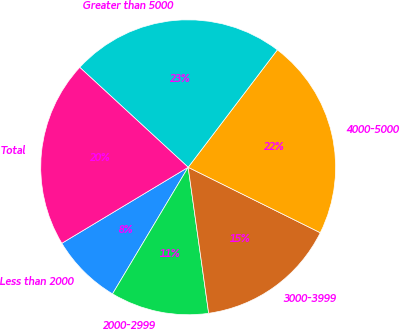<chart> <loc_0><loc_0><loc_500><loc_500><pie_chart><fcel>Less than 2000<fcel>2000-2999<fcel>3000-3999<fcel>4000-5000<fcel>Greater than 5000<fcel>Total<nl><fcel>7.81%<fcel>10.79%<fcel>15.46%<fcel>21.98%<fcel>23.49%<fcel>20.47%<nl></chart> 